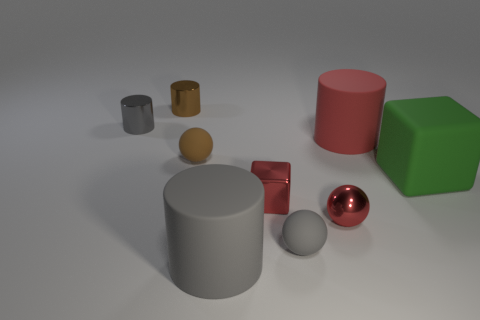Are there any patterns in the colors of the objects? While no repetitive patterns are evident, the objects exhibit a variety of colors including red, green, brown and shades of gray. The colors do not follow a particular pattern, but they are distinctively different from each other, which may indicate an intention to contrast the objects for visual or experimental purposes. 